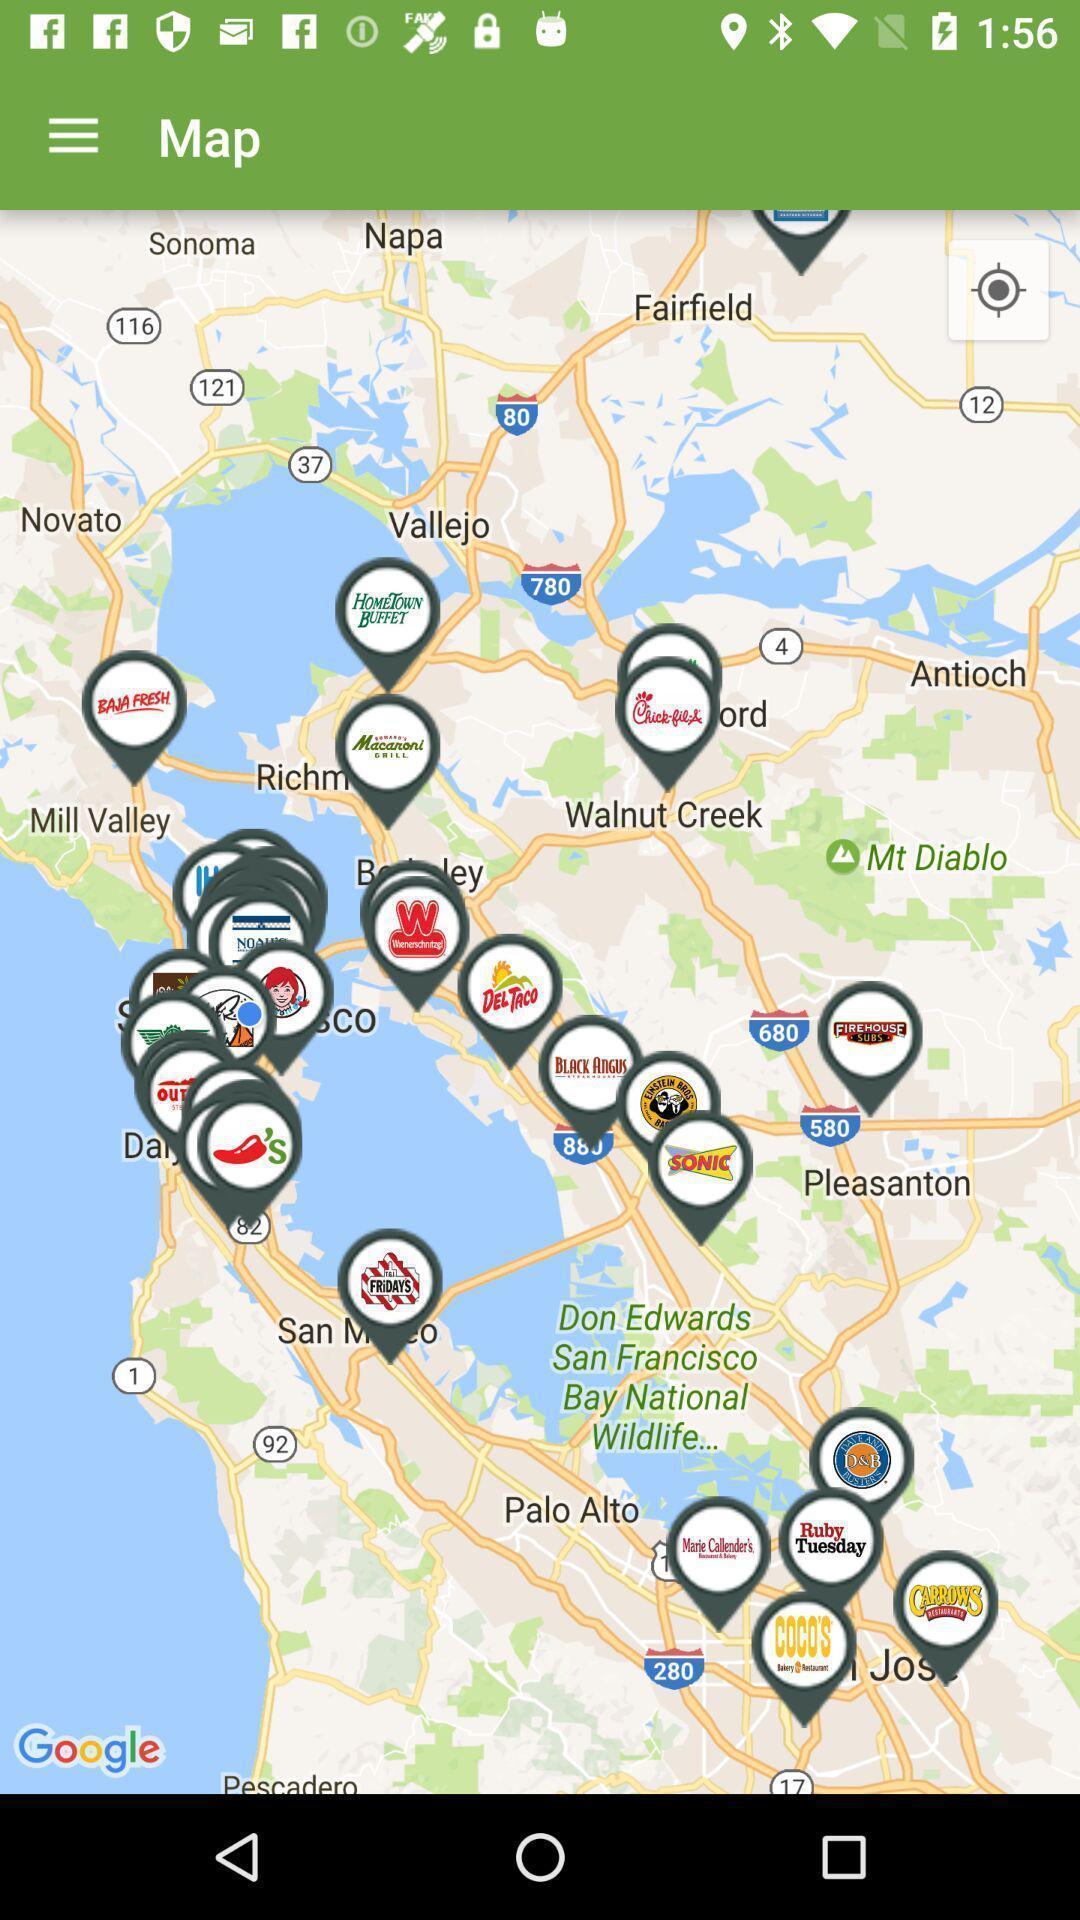Provide a textual representation of this image. Phone maps shows the location of restaurants. 